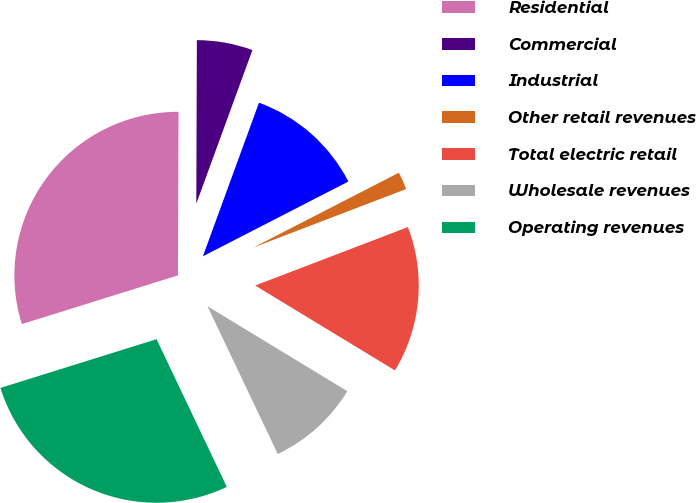Convert chart. <chart><loc_0><loc_0><loc_500><loc_500><pie_chart><fcel>Residential<fcel>Commercial<fcel>Industrial<fcel>Other retail revenues<fcel>Total electric retail<fcel>Wholesale revenues<fcel>Operating revenues<nl><fcel>29.87%<fcel>5.52%<fcel>11.87%<fcel>1.74%<fcel>14.5%<fcel>9.25%<fcel>27.25%<nl></chart> 